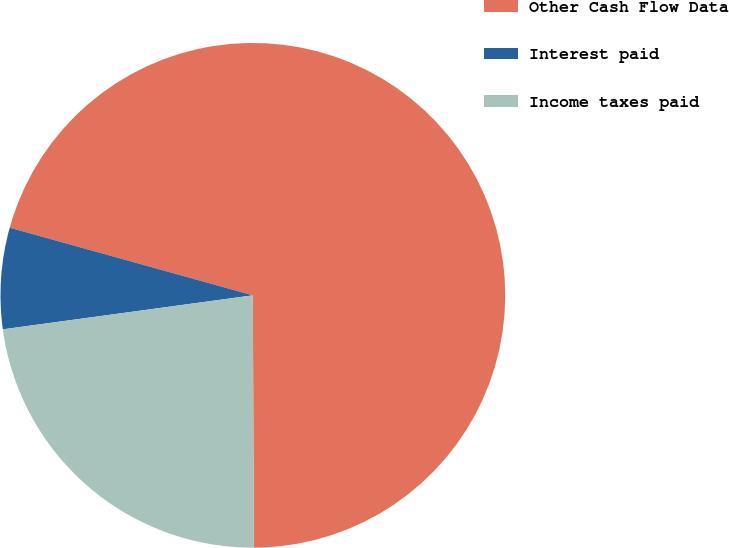Convert chart to OTSL. <chart><loc_0><loc_0><loc_500><loc_500><pie_chart><fcel>Other Cash Flow Data<fcel>Interest paid<fcel>Income taxes paid<nl><fcel>70.62%<fcel>6.47%<fcel>22.91%<nl></chart> 